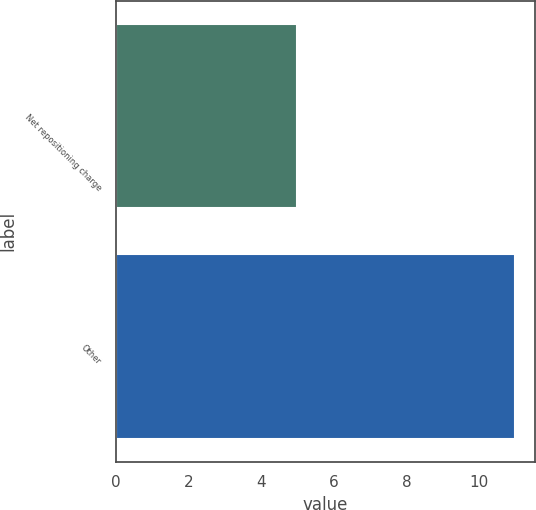<chart> <loc_0><loc_0><loc_500><loc_500><bar_chart><fcel>Net repositioning charge<fcel>Other<nl><fcel>5<fcel>11<nl></chart> 